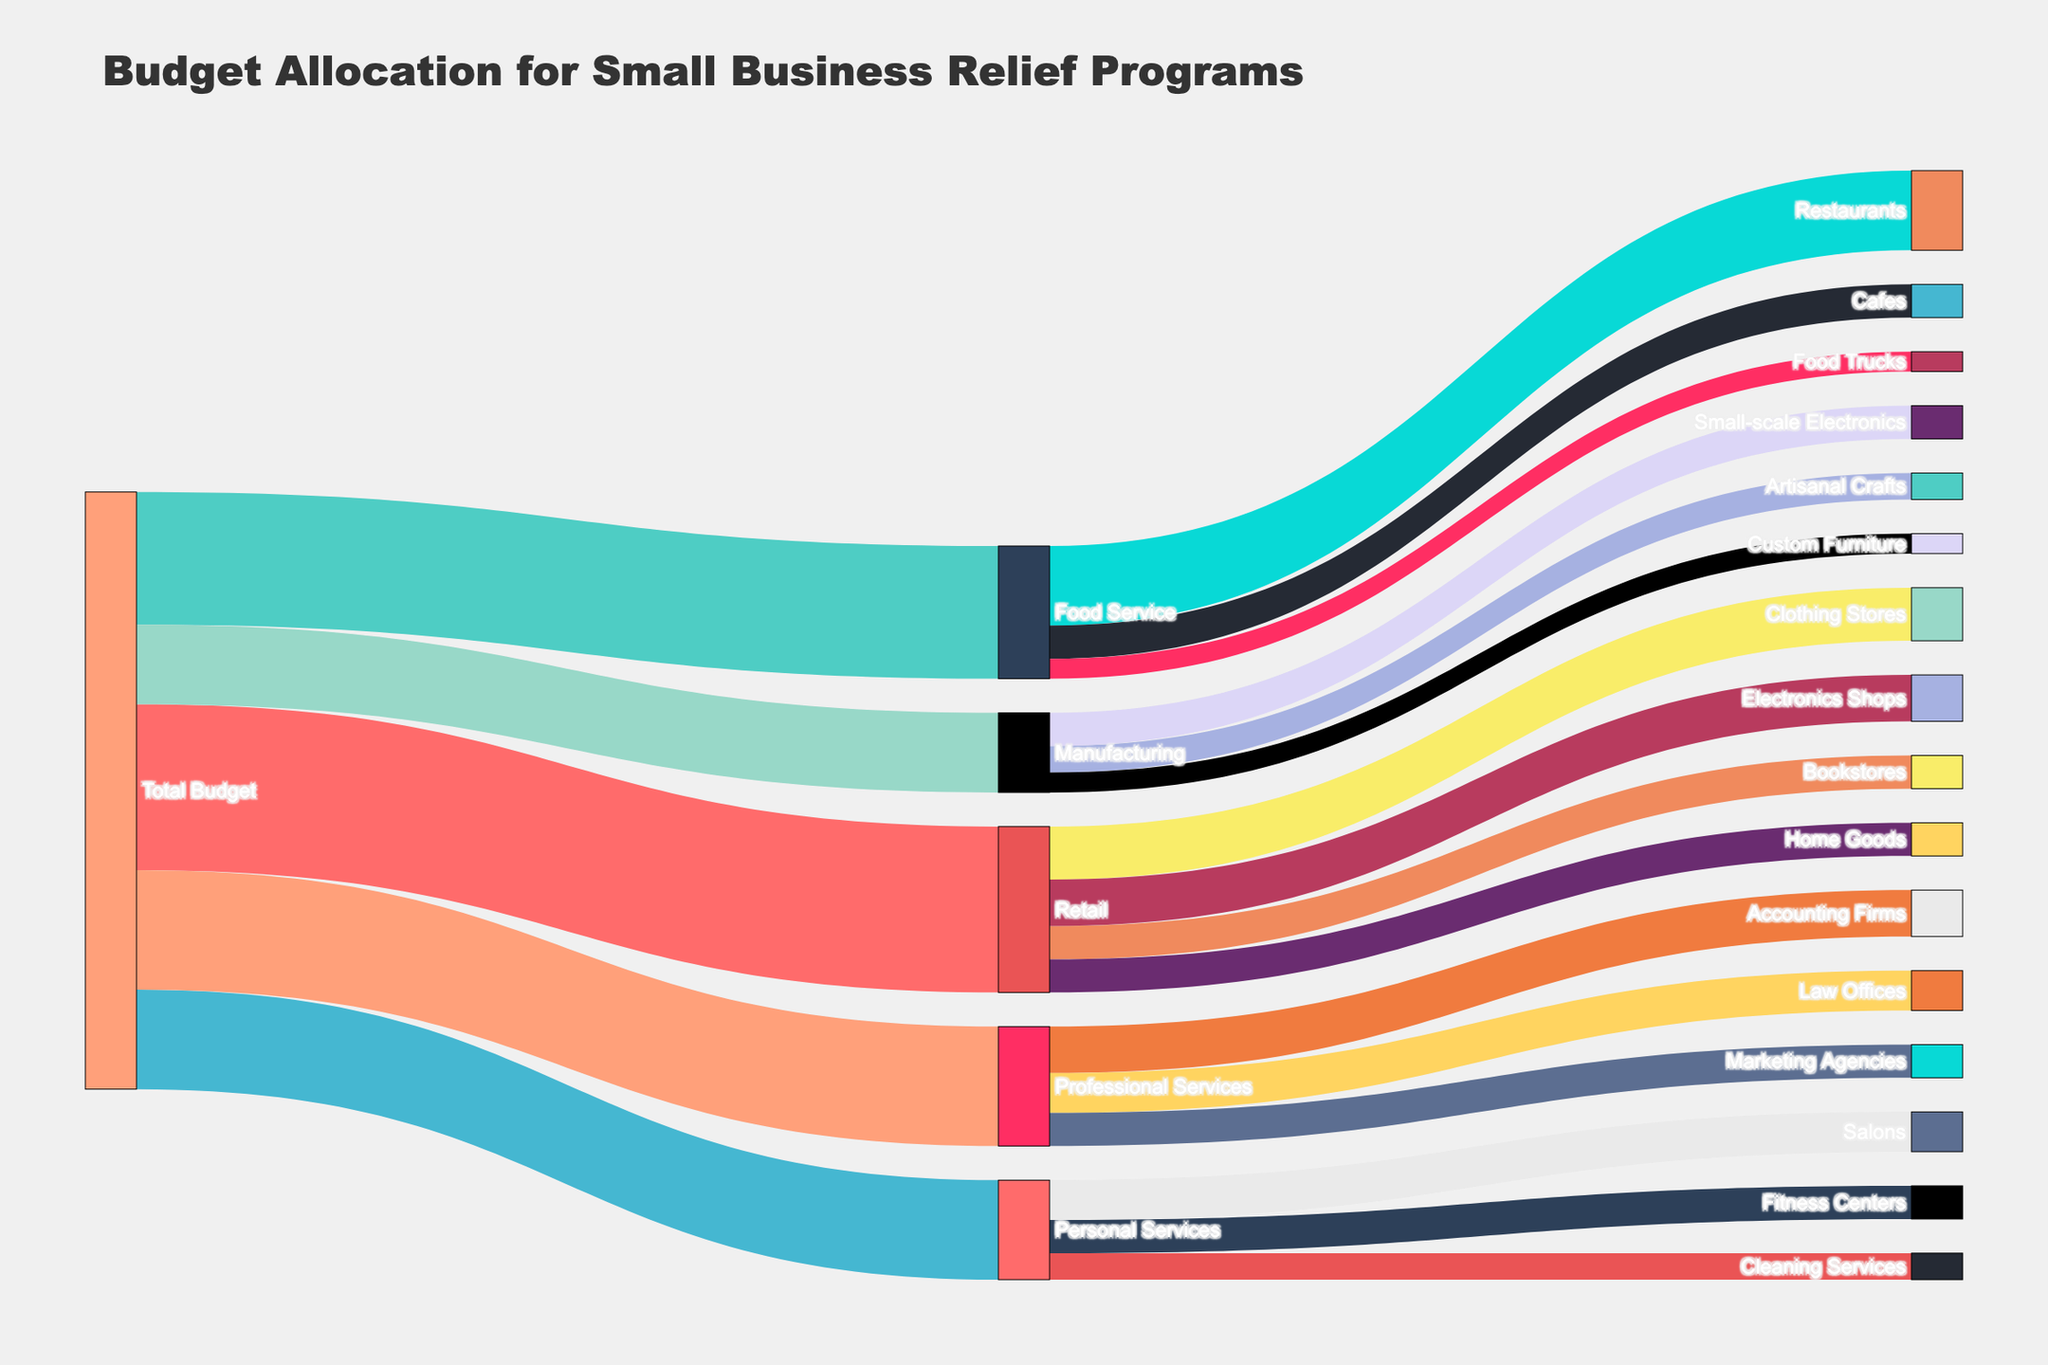What's the total budget allocated for small business relief programs? The Sankey Diagram shows the total budget flowing into different sectors from a single source, labeled "Total Budget." The sum of all values flowing from "Total Budget" to sectors gives the total budget. Summing up 2500000 (Retail) + 2000000 (Food Service) + 1500000 (Personal Services) + 1800000 (Professional Services) + 1200000 (Manufacturing) gives the total budget of 9000000.
Answer: 9000000 Which sector receives the highest budget allocation? By observing the width of the flows emanating from "Total Budget" to each sector, Retail has the widest flow representing a budget of 2500000, which is higher than any other sector.
Answer: Retail How much budget is allocated to Restaurants within the Food Service sector? The diagram shows the flow from Food Service to its subcategories. The flow labeled "Restaurants" from Food Service shows an allocation of 1200000.
Answer: 1200000 What is the total budget allocated to Professional Services? The value represented by the flow from "Total Budget" to "Professional Services" is labeled as 1800000.
Answer: 1800000 What is the combined budget allocated to Manufacturing and Retail? Add the allocations for Manufacturing and Retail, which are represented by the flows from "Total Budget" to these sectors. Manufacturing has 1200000 and Retail has 2500000. Summing these gives 3700000.
Answer: 3700000 Compare the budget allocated to Salons and Law Offices. Which receives more, and by how much? According to the diagram, Salons receive 600000, and Law Offices receive 600000. The difference between these allocations is 0.
Answer: Both receive the same amount Which subcategory within Manufacturing receives the smallest budget? The flows within Manufacturing indicate subcategories: Artisanal Crafts (400000), Small-scale Electronics (500000), and Custom Furniture (300000). The smallest flow is to Custom Furniture, with 300000.
Answer: Custom Furniture What is the budget allocation discrepancy between Food Trucks and Electronics Shops? The diagram shows Food Trucks receive 300000, while Electronics Shops receive 700000. Subtracting the smaller allocation from the larger gives 700000 - 300000 = 400000.
Answer: 400000 Sum the budget allocations for all subcategories under Retail. The subcategories under Retail and their budgets are Clothing Stores (800000), Bookstores (500000), Electronics Shops (700000), Home Goods (500000). Summing these: 800000 + 500000 + 700000 + 500000 = 2500000.
Answer: 2500000 